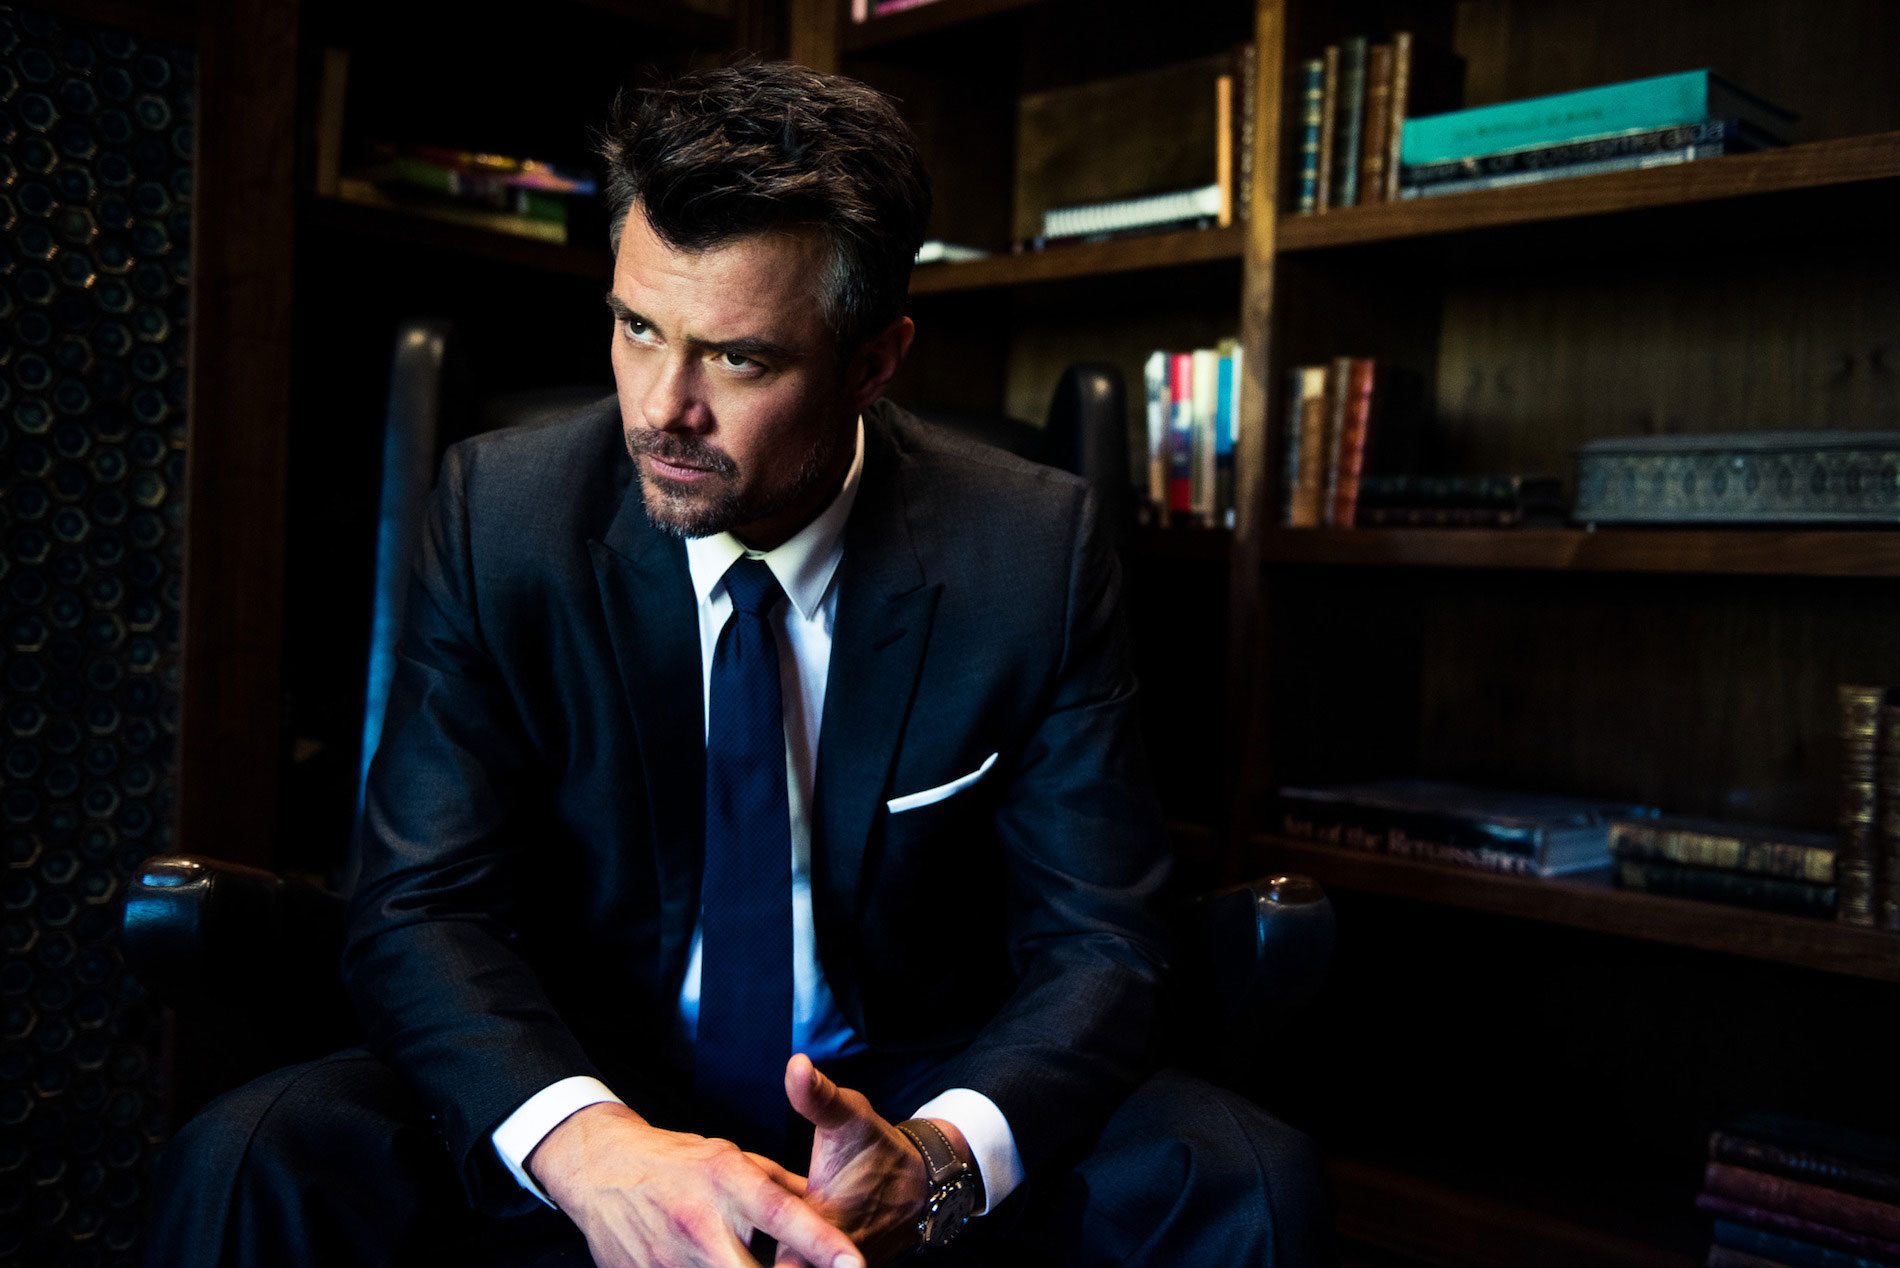What is the mood conveyed by the person in this image? The mood conveyed by the person in this image appears to be one of deep contemplation or introspection. The dim lighting and his thoughtful expression, combined with his formal attire, suggest a serious and reflective atmosphere. Why do you think he might be feeling this way? The setting implies he might be in a professional environment, possibly thinking about a significant decision or reflecting on a recent event. His formal attire and the serious expression could indicate he's dealing with a challenging situation or contemplating an important matter. What book titles can you spot in the background? While the titles aren't completely clear, the bookshelf behind him contains various books that appear to include titles related to art and the Renaissance era. These books might provide context clues to the intellectual or professional nature of the setting. 